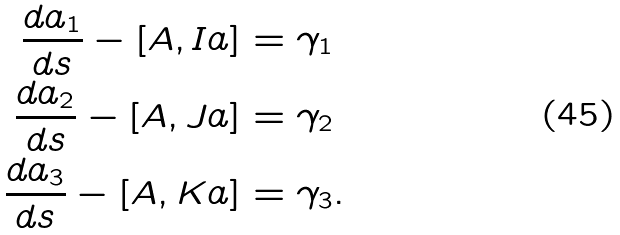Convert formula to latex. <formula><loc_0><loc_0><loc_500><loc_500>\frac { d a _ { 1 } } { d s } - [ A , I a ] & = \gamma _ { 1 } \\ \frac { d a _ { 2 } } { d s } - [ A , J a ] & = \gamma _ { 2 } \\ \frac { d a _ { 3 } } { d s } - [ A , K a ] & = \gamma _ { 3 } .</formula> 